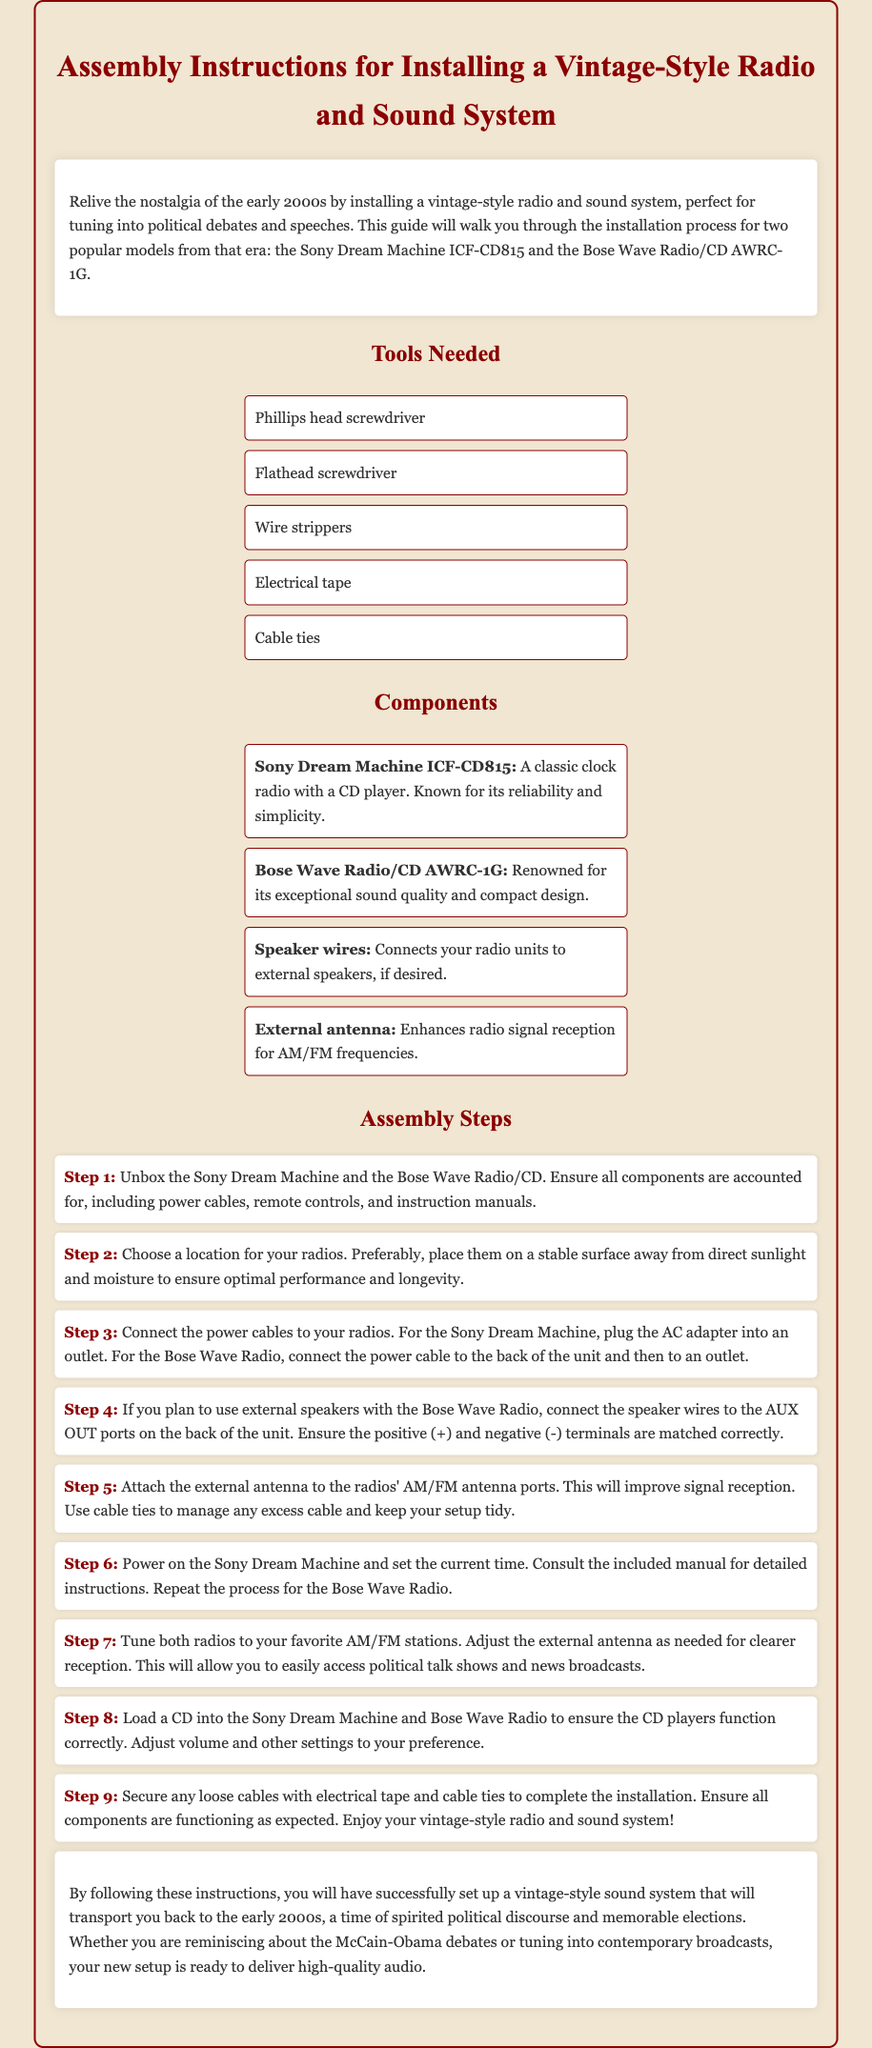What are the two models mentioned? The document mentions two models: the Sony Dream Machine ICF-CD815 and the Bose Wave Radio/CD AWRC-1G.
Answer: Sony Dream Machine ICF-CD815, Bose Wave Radio/CD AWRC-1G How many tools are listed in the document? The document lists five tools that are needed for the assembly.
Answer: 5 What is the primary use of the external antenna? The external antenna is meant to enhance radio signal reception for AM/FM frequencies.
Answer: Enhance radio signal reception Which component connects the radios to external speakers? The component used to connect the radios to external speakers is speaker wires.
Answer: Speaker wires What should you do after loading a CD into the radios? After loading a CD, you should adjust volume and other settings to your preference.
Answer: Adjust volume and settings Where should you ideally place the radios? The radios should be placed on a stable surface away from direct sunlight and moisture.
Answer: Stable surface away from sunlight and moisture What is the final step in the assembly process? The final step involves securing any loose cables with electrical tape and cable ties.
Answer: Secure loose cables Which radio model is described as being renowned for exceptional sound quality? The Bose Wave Radio/CD AWRC-1G is described as renowned for its exceptional sound quality.
Answer: Bose Wave Radio/CD AWRC-1G 